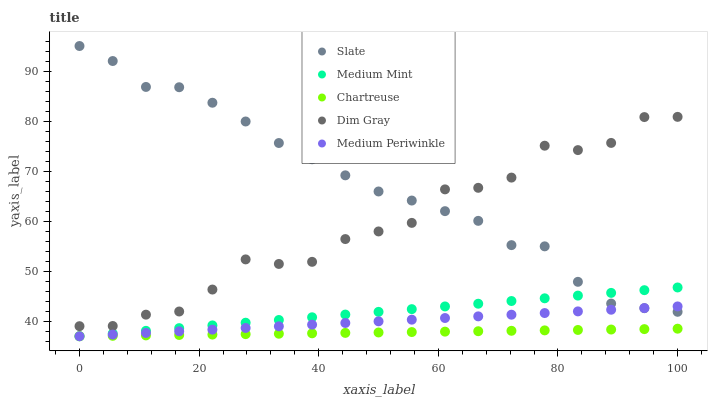Does Chartreuse have the minimum area under the curve?
Answer yes or no. Yes. Does Slate have the maximum area under the curve?
Answer yes or no. Yes. Does Dim Gray have the minimum area under the curve?
Answer yes or no. No. Does Dim Gray have the maximum area under the curve?
Answer yes or no. No. Is Chartreuse the smoothest?
Answer yes or no. Yes. Is Dim Gray the roughest?
Answer yes or no. Yes. Is Slate the smoothest?
Answer yes or no. No. Is Slate the roughest?
Answer yes or no. No. Does Medium Mint have the lowest value?
Answer yes or no. Yes. Does Dim Gray have the lowest value?
Answer yes or no. No. Does Slate have the highest value?
Answer yes or no. Yes. Does Dim Gray have the highest value?
Answer yes or no. No. Is Chartreuse less than Slate?
Answer yes or no. Yes. Is Slate greater than Chartreuse?
Answer yes or no. Yes. Does Chartreuse intersect Medium Periwinkle?
Answer yes or no. Yes. Is Chartreuse less than Medium Periwinkle?
Answer yes or no. No. Is Chartreuse greater than Medium Periwinkle?
Answer yes or no. No. Does Chartreuse intersect Slate?
Answer yes or no. No. 